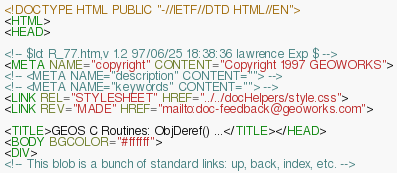Convert code to text. <code><loc_0><loc_0><loc_500><loc_500><_HTML_><!DOCTYPE HTML PUBLIC "-//IETF//DTD HTML//EN">
<HTML>
<HEAD>

<!-- $Id: R_77.htm,v 1.2 97/06/25 18:38:36 lawrence Exp $ -->
<META NAME="copyright" CONTENT="Copyright 1997 GEOWORKS">
<!-- <META NAME="description" CONTENT=""> -->
<!-- <META NAME="keywords" CONTENT=""> -->
<LINK REL="STYLESHEET" HREF="../../docHelpers/style.css">
<LINK REV="MADE" HREF="mailto:doc-feedback@geoworks.com">

<TITLE>GEOS C Routines: ObjDeref() ...</TITLE></HEAD>
<BODY BGCOLOR="#ffffff">
<DIV>
<!-- This blob is a bunch of standard links: up, back, index, etc. --></code> 